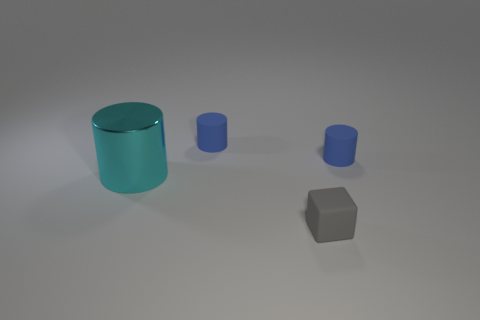Subtract all yellow cubes. Subtract all cyan balls. How many cubes are left? 1 Add 1 cyan metallic things. How many objects exist? 5 Subtract all cylinders. How many objects are left? 1 Subtract 0 gray cylinders. How many objects are left? 4 Subtract all large green shiny spheres. Subtract all gray matte things. How many objects are left? 3 Add 3 cubes. How many cubes are left? 4 Add 3 large cyan cylinders. How many large cyan cylinders exist? 4 